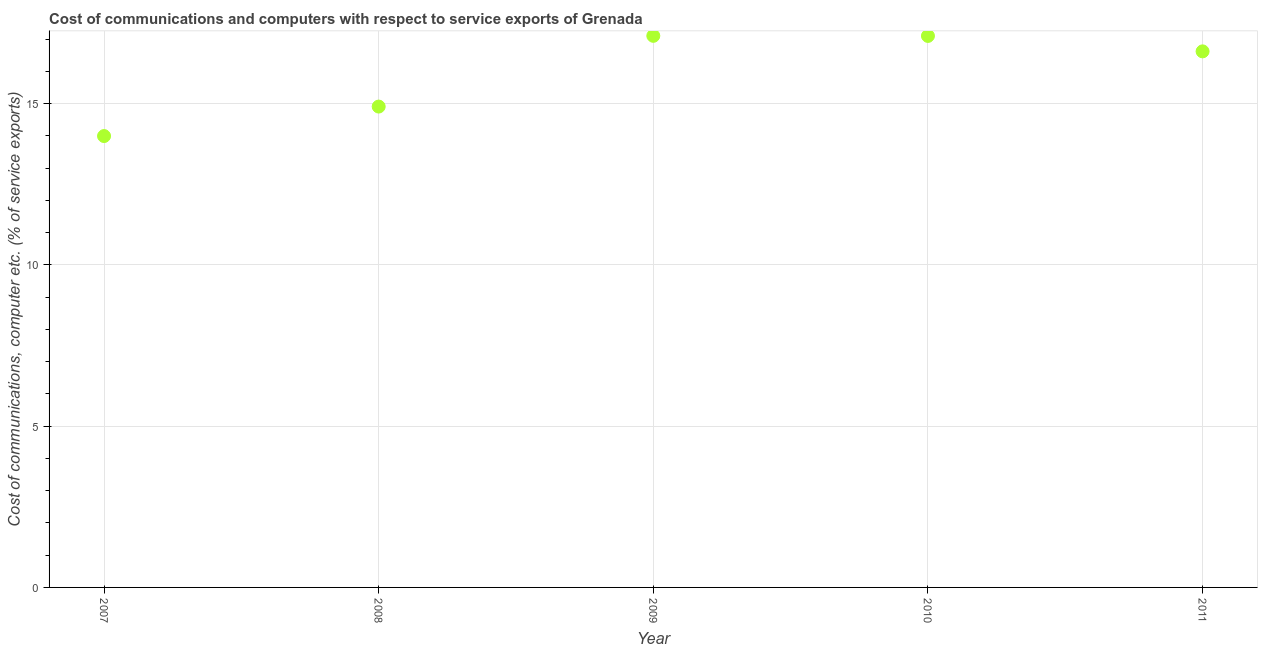What is the cost of communications and computer in 2011?
Give a very brief answer. 16.62. Across all years, what is the maximum cost of communications and computer?
Give a very brief answer. 17.1. Across all years, what is the minimum cost of communications and computer?
Provide a short and direct response. 13.99. In which year was the cost of communications and computer minimum?
Give a very brief answer. 2007. What is the sum of the cost of communications and computer?
Keep it short and to the point. 79.72. What is the difference between the cost of communications and computer in 2009 and 2011?
Your response must be concise. 0.48. What is the average cost of communications and computer per year?
Your response must be concise. 15.94. What is the median cost of communications and computer?
Your response must be concise. 16.62. In how many years, is the cost of communications and computer greater than 9 %?
Provide a short and direct response. 5. Do a majority of the years between 2007 and 2011 (inclusive) have cost of communications and computer greater than 2 %?
Keep it short and to the point. Yes. What is the ratio of the cost of communications and computer in 2008 to that in 2009?
Provide a succinct answer. 0.87. Is the cost of communications and computer in 2007 less than that in 2010?
Ensure brevity in your answer.  Yes. What is the difference between the highest and the second highest cost of communications and computer?
Ensure brevity in your answer.  0. What is the difference between the highest and the lowest cost of communications and computer?
Your answer should be very brief. 3.11. Does the cost of communications and computer monotonically increase over the years?
Your answer should be compact. No. How many dotlines are there?
Offer a terse response. 1. What is the difference between two consecutive major ticks on the Y-axis?
Offer a very short reply. 5. Does the graph contain grids?
Ensure brevity in your answer.  Yes. What is the title of the graph?
Keep it short and to the point. Cost of communications and computers with respect to service exports of Grenada. What is the label or title of the Y-axis?
Provide a succinct answer. Cost of communications, computer etc. (% of service exports). What is the Cost of communications, computer etc. (% of service exports) in 2007?
Keep it short and to the point. 13.99. What is the Cost of communications, computer etc. (% of service exports) in 2008?
Your answer should be very brief. 14.91. What is the Cost of communications, computer etc. (% of service exports) in 2009?
Make the answer very short. 17.1. What is the Cost of communications, computer etc. (% of service exports) in 2010?
Provide a short and direct response. 17.1. What is the Cost of communications, computer etc. (% of service exports) in 2011?
Provide a short and direct response. 16.62. What is the difference between the Cost of communications, computer etc. (% of service exports) in 2007 and 2008?
Offer a very short reply. -0.91. What is the difference between the Cost of communications, computer etc. (% of service exports) in 2007 and 2009?
Give a very brief answer. -3.11. What is the difference between the Cost of communications, computer etc. (% of service exports) in 2007 and 2010?
Your answer should be very brief. -3.1. What is the difference between the Cost of communications, computer etc. (% of service exports) in 2007 and 2011?
Ensure brevity in your answer.  -2.63. What is the difference between the Cost of communications, computer etc. (% of service exports) in 2008 and 2009?
Keep it short and to the point. -2.19. What is the difference between the Cost of communications, computer etc. (% of service exports) in 2008 and 2010?
Make the answer very short. -2.19. What is the difference between the Cost of communications, computer etc. (% of service exports) in 2008 and 2011?
Offer a terse response. -1.71. What is the difference between the Cost of communications, computer etc. (% of service exports) in 2009 and 2010?
Your response must be concise. 0. What is the difference between the Cost of communications, computer etc. (% of service exports) in 2009 and 2011?
Keep it short and to the point. 0.48. What is the difference between the Cost of communications, computer etc. (% of service exports) in 2010 and 2011?
Your answer should be very brief. 0.48. What is the ratio of the Cost of communications, computer etc. (% of service exports) in 2007 to that in 2008?
Provide a succinct answer. 0.94. What is the ratio of the Cost of communications, computer etc. (% of service exports) in 2007 to that in 2009?
Make the answer very short. 0.82. What is the ratio of the Cost of communications, computer etc. (% of service exports) in 2007 to that in 2010?
Offer a terse response. 0.82. What is the ratio of the Cost of communications, computer etc. (% of service exports) in 2007 to that in 2011?
Offer a very short reply. 0.84. What is the ratio of the Cost of communications, computer etc. (% of service exports) in 2008 to that in 2009?
Provide a short and direct response. 0.87. What is the ratio of the Cost of communications, computer etc. (% of service exports) in 2008 to that in 2010?
Your answer should be very brief. 0.87. What is the ratio of the Cost of communications, computer etc. (% of service exports) in 2008 to that in 2011?
Provide a short and direct response. 0.9. What is the ratio of the Cost of communications, computer etc. (% of service exports) in 2009 to that in 2010?
Give a very brief answer. 1. What is the ratio of the Cost of communications, computer etc. (% of service exports) in 2010 to that in 2011?
Offer a very short reply. 1.03. 